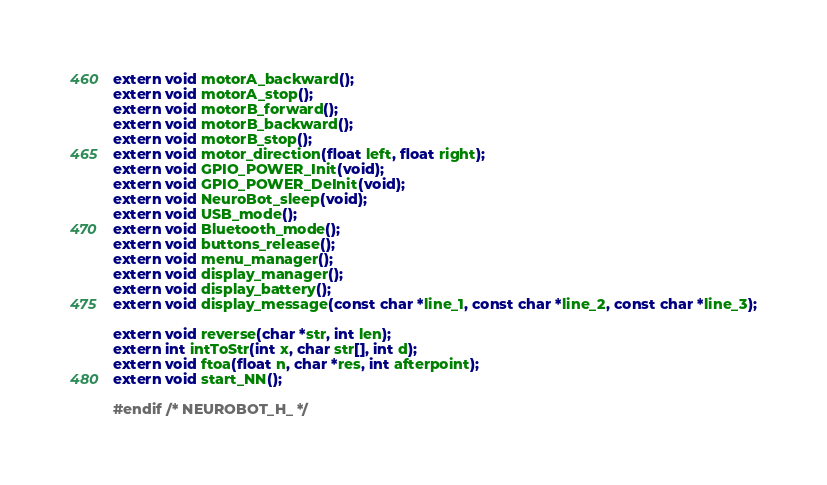<code> <loc_0><loc_0><loc_500><loc_500><_C_>extern void motorA_backward();
extern void motorA_stop();
extern void motorB_forward();
extern void motorB_backward();
extern void motorB_stop();
extern void motor_direction(float left, float right);
extern void GPIO_POWER_Init(void);
extern void GPIO_POWER_DeInit(void);
extern void NeuroBot_sleep(void);
extern void USB_mode();
extern void Bluetooth_mode();
extern void buttons_release();
extern void menu_manager();
extern void display_manager();
extern void display_battery();
extern void display_message(const char *line_1, const char *line_2, const char *line_3);

extern void reverse(char *str, int len);
extern int intToStr(int x, char str[], int d);
extern void ftoa(float n, char *res, int afterpoint);
extern void start_NN();

#endif /* NEUROBOT_H_ */
</code> 